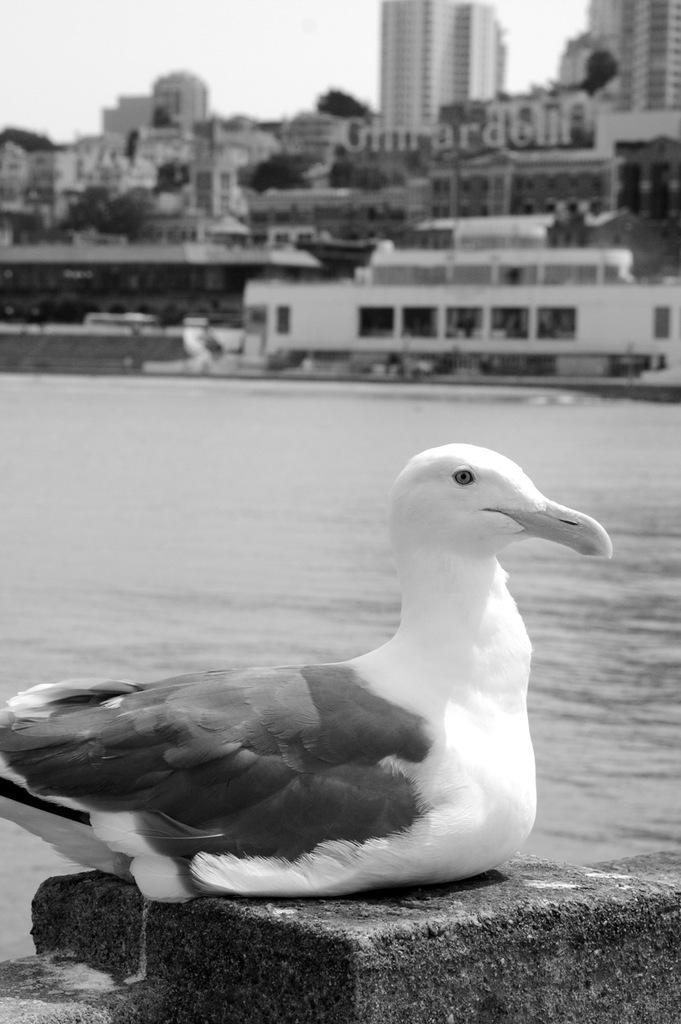What animal is present in the image? There is a duck in the image. Where is the duck located? The duck is sitting on a wall. What can be seen in the background of the image? There is a river, buildings, and trees in the background of the image. What is the color scheme of the image? The image is black and white. Who is the manager of the duck in the image? There is no manager present in the image, as it features a duck sitting on a wall. What type of toy can be seen in the image? There are no toys present in the image. 